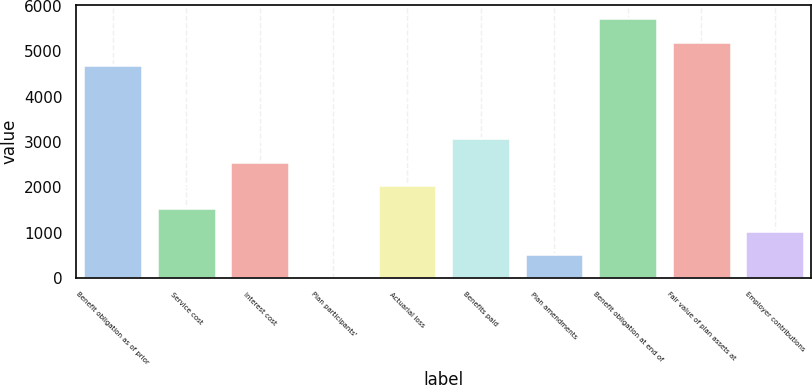Convert chart to OTSL. <chart><loc_0><loc_0><loc_500><loc_500><bar_chart><fcel>Benefit obligation as of prior<fcel>Service cost<fcel>Interest cost<fcel>Plan participants'<fcel>Actuarial loss<fcel>Benefits paid<fcel>Plan amendments<fcel>Benefit obligation at end of<fcel>Fair value of plan assets at<fcel>Employer contributions<nl><fcel>4705<fcel>1541.3<fcel>2567.5<fcel>2<fcel>2054.4<fcel>3080.6<fcel>515.1<fcel>5731.2<fcel>5218.1<fcel>1028.2<nl></chart> 